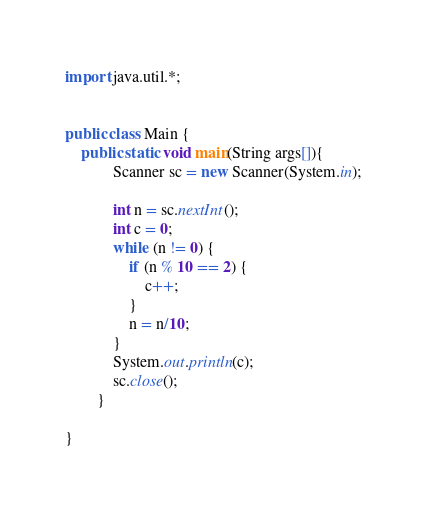<code> <loc_0><loc_0><loc_500><loc_500><_Java_>import java.util.*;


public class Main {
    public static void main(String args[]){
            Scanner sc = new Scanner(System.in);
           
            int n = sc.nextInt();
            int c = 0;
            while (n != 0) {
                if (n % 10 == 2) {
                    c++;
                }
                n = n/10;
            }
            System.out.println(c);
            sc.close();
        }
    
}

</code> 